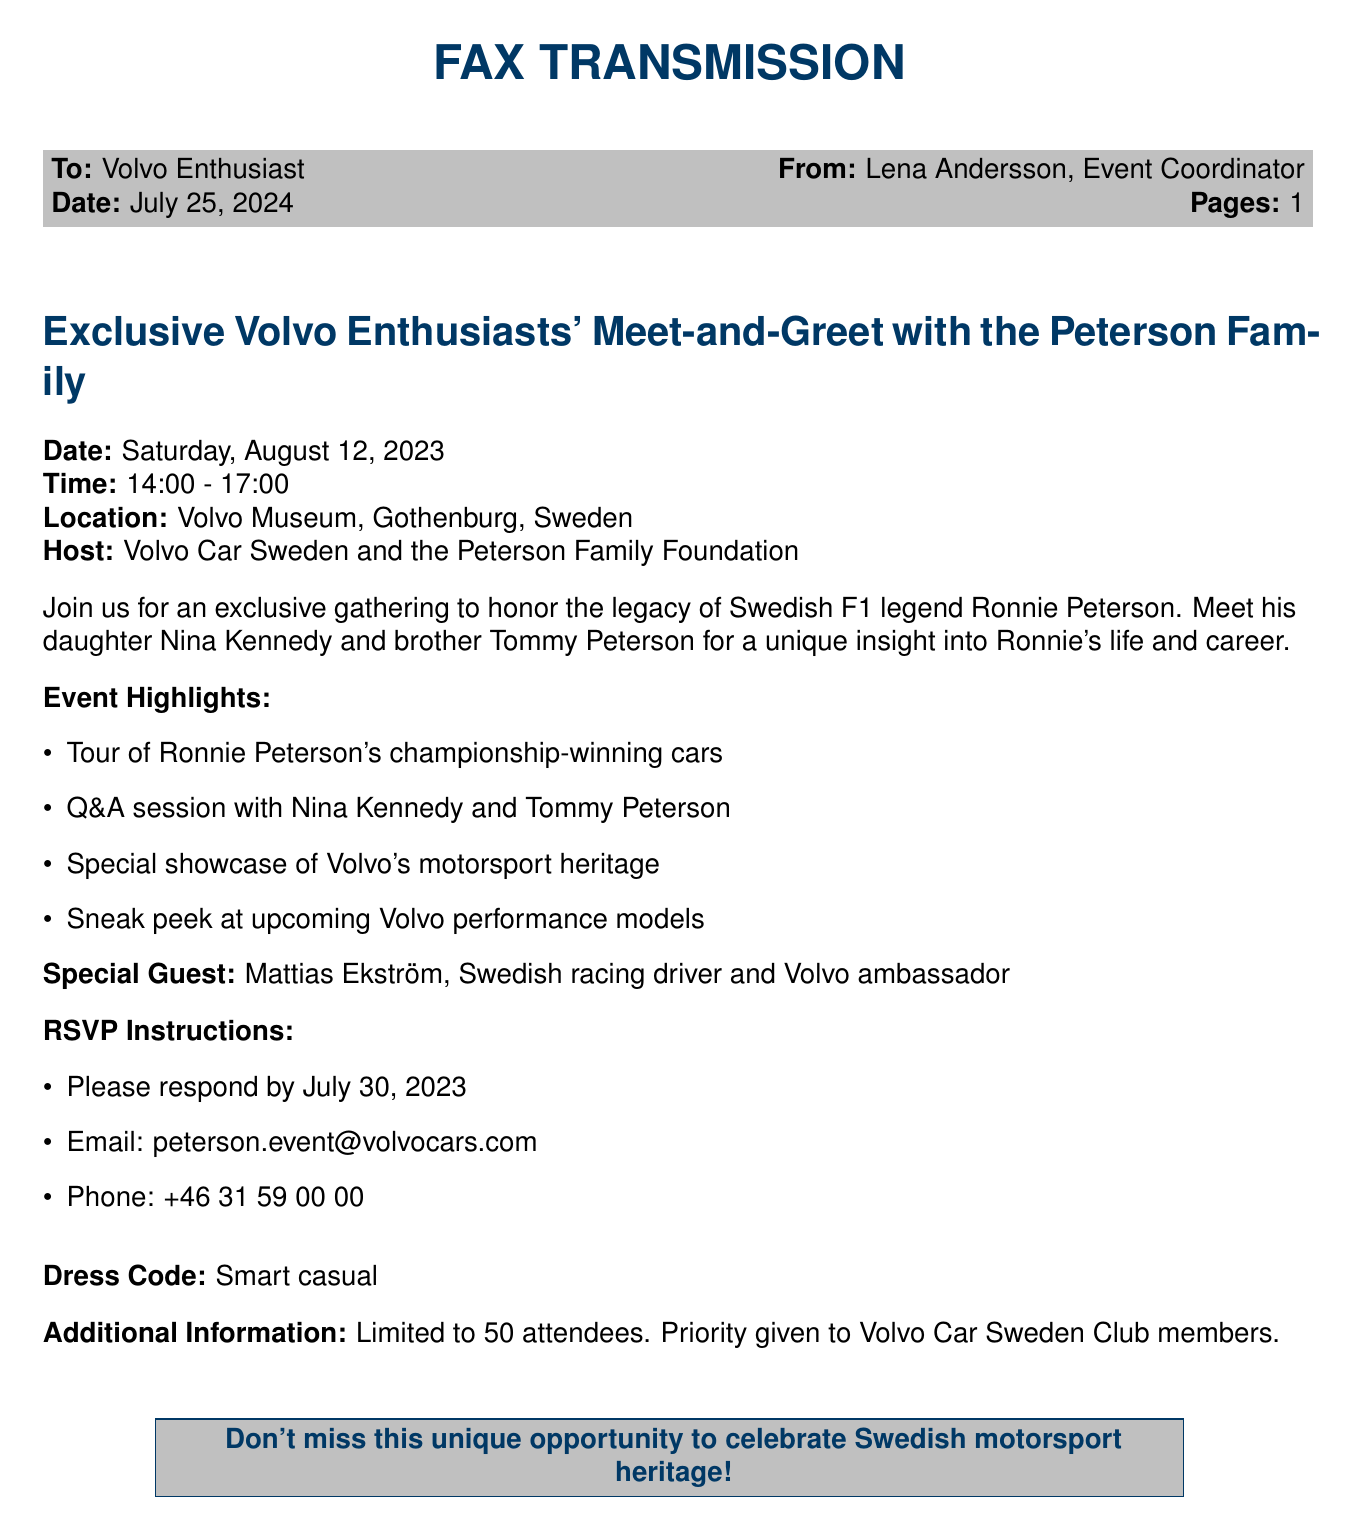What is the date of the event? The event is scheduled for Saturday, August 12, 2023, as mentioned in the document.
Answer: August 12, 2023 What time does the event start? The document specifies the event time from 14:00, indicating the starting time.
Answer: 14:00 Where is the meet-and-greet taking place? The location stated in the document is the Volvo Museum in Gothenburg, Sweden.
Answer: Volvo Museum, Gothenburg, Sweden Who is the special guest? The document mentions Mattias Ekström as the special guest at the event.
Answer: Mattias Ekström What highlights will be featured at the event? A list of event highlights includes a tour of Ronnie Peterson's cars and a Q&A session, among others.
Answer: Tour of Ronnie Peterson's championship-winning cars What is the RSVP deadline? The document clearly states the RSVP deadline as July 30, 2023.
Answer: July 30, 2023 Who is hosting the event? The document indicates that the event is hosted by Volvo Car Sweden and the Peterson Family Foundation.
Answer: Volvo Car Sweden and the Peterson Family Foundation What is the dress code for attendees? The document specifies the dress code for the event as smart casual.
Answer: Smart casual How many attendees are allowed at the event? The document states that the event is limited to 50 attendees.
Answer: 50 attendees 